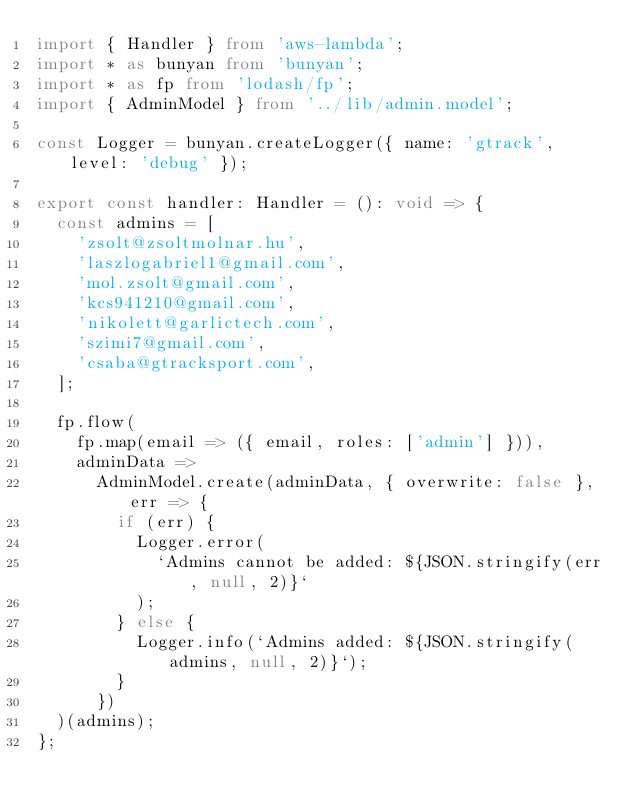Convert code to text. <code><loc_0><loc_0><loc_500><loc_500><_TypeScript_>import { Handler } from 'aws-lambda';
import * as bunyan from 'bunyan';
import * as fp from 'lodash/fp';
import { AdminModel } from '../lib/admin.model';

const Logger = bunyan.createLogger({ name: 'gtrack', level: 'debug' });

export const handler: Handler = (): void => {
  const admins = [
    'zsolt@zsoltmolnar.hu',
    'laszlogabriel1@gmail.com',
    'mol.zsolt@gmail.com',
    'kcs941210@gmail.com',
    'nikolett@garlictech.com',
    'szimi7@gmail.com',
    'csaba@gtracksport.com',
  ];

  fp.flow(
    fp.map(email => ({ email, roles: ['admin'] })),
    adminData =>
      AdminModel.create(adminData, { overwrite: false }, err => {
        if (err) {
          Logger.error(
            `Admins cannot be added: ${JSON.stringify(err, null, 2)}`
          );
        } else {
          Logger.info(`Admins added: ${JSON.stringify(admins, null, 2)}`);
        }
      })
  )(admins);
};
</code> 